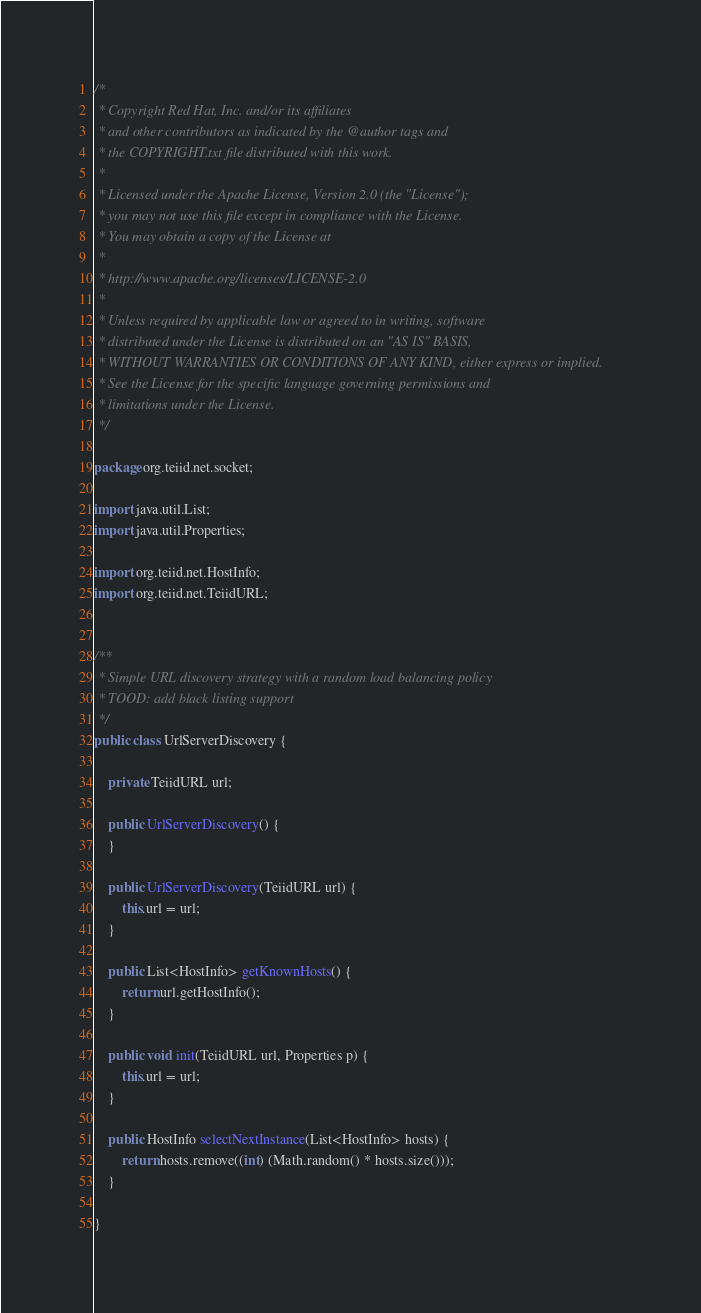Convert code to text. <code><loc_0><loc_0><loc_500><loc_500><_Java_>/*
 * Copyright Red Hat, Inc. and/or its affiliates
 * and other contributors as indicated by the @author tags and
 * the COPYRIGHT.txt file distributed with this work.
 *
 * Licensed under the Apache License, Version 2.0 (the "License");
 * you may not use this file except in compliance with the License.
 * You may obtain a copy of the License at
 *
 * http://www.apache.org/licenses/LICENSE-2.0
 *
 * Unless required by applicable law or agreed to in writing, software
 * distributed under the License is distributed on an "AS IS" BASIS,
 * WITHOUT WARRANTIES OR CONDITIONS OF ANY KIND, either express or implied.
 * See the License for the specific language governing permissions and
 * limitations under the License.
 */

package org.teiid.net.socket;

import java.util.List;
import java.util.Properties;

import org.teiid.net.HostInfo;
import org.teiid.net.TeiidURL;


/**
 * Simple URL discovery strategy with a random load balancing policy
 * TOOD: add black listing support
 */
public class UrlServerDiscovery {

    private TeiidURL url;

    public UrlServerDiscovery() {
    }

    public UrlServerDiscovery(TeiidURL url) {
        this.url = url;
    }

    public List<HostInfo> getKnownHosts() {
        return url.getHostInfo();
    }

    public void init(TeiidURL url, Properties p) {
        this.url = url;
    }

    public HostInfo selectNextInstance(List<HostInfo> hosts) {
        return hosts.remove((int) (Math.random() * hosts.size()));
    }

}
</code> 